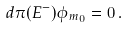<formula> <loc_0><loc_0><loc_500><loc_500>d \pi ( E ^ { - } ) \phi _ { m _ { 0 } } = 0 \, .</formula> 